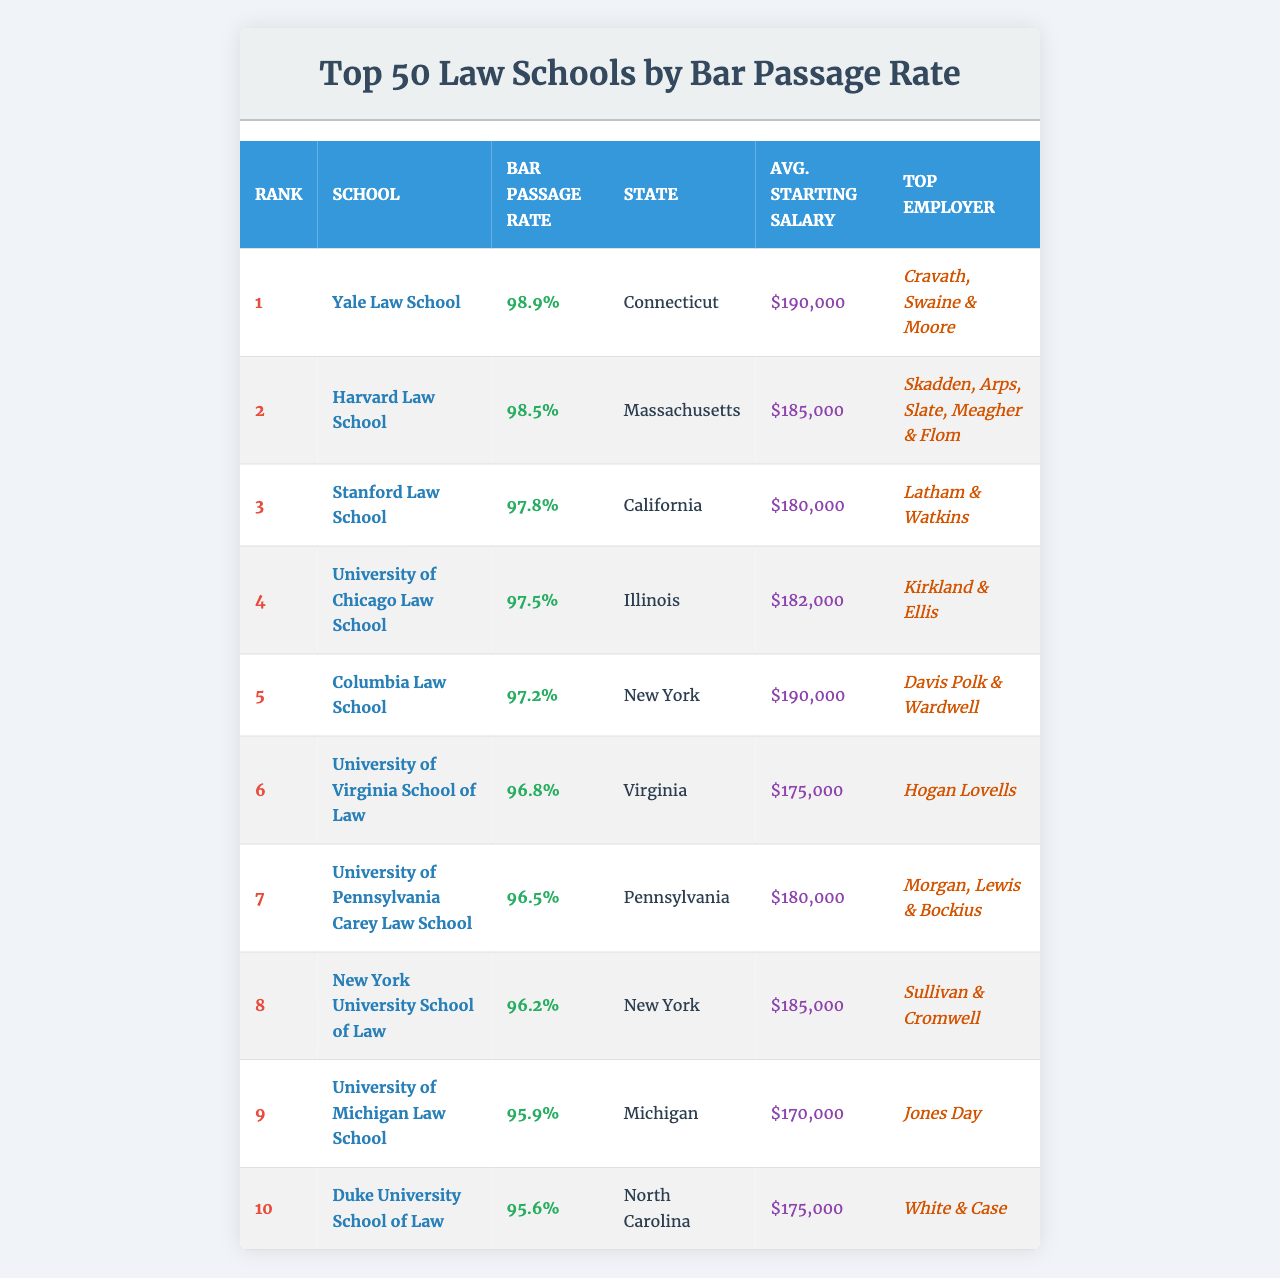What is the highest bar passage rate among the top 10 law schools? The table shows that Yale Law School has the highest bar passage rate of 98.9%.
Answer: 98.9% Which school has the top employer listed as Kirkland & Ellis? Referring to the table, the University of Chicago Law School is associated with Kirkland & Ellis.
Answer: University of Chicago Law School What is the average starting salary of the law school ranking 5th? According to the table, Columbia Law School, which ranks 5th, has an average starting salary of $190,000.
Answer: $190,000 Is the bar passage rate of Duke University School of Law above 95%? The data indicates that Duke University School of Law has a bar passage rate of 95.6%, which is indeed above 95%.
Answer: Yes What is the difference in bar passage rates between Yale Law School and Stanford Law School? Yale Law School's bar passage rate is 98.9%, while Stanford Law School's is 97.8%. The difference is 98.9% - 97.8% = 1.1%.
Answer: 1.1% Which school has the lowest bar passage rate among the top 10? By examining the table, Duke University School of Law has the lowest bar passage rate in the top 10, which is 95.6%.
Answer: Duke University School of Law What would be the average starting salary of the top two schools? The average starting salary for Yale Law School is $190,000 and for Harvard Law School it is $185,000. The sum is $190,000 + $185,000 = $375,000. The average is $375,000 / 2 = $187,500.
Answer: $187,500 Which state has the school with the highest bar passage rate? From the table, Connecticut is the state of Yale Law School, which has the highest bar passage rate.
Answer: Connecticut Do any of the top 10 law schools have a bar passage rate below 96%? Reviewing the table, the University of Michigan Law School has a bar passage rate of 95.9%, which is below 96%.
Answer: Yes What is the combined average starting salary of the schools ranked 1st to 3rd? The average starting salaries for Yale Law School, Harvard Law School, and Stanford Law School are $190,000, $185,000, and $180,000 respectively. Their combined total is $190,000 + $185,000 + $180,000 = $555,000. Dividing by 3 gives an average of $185,000.
Answer: $185,000 